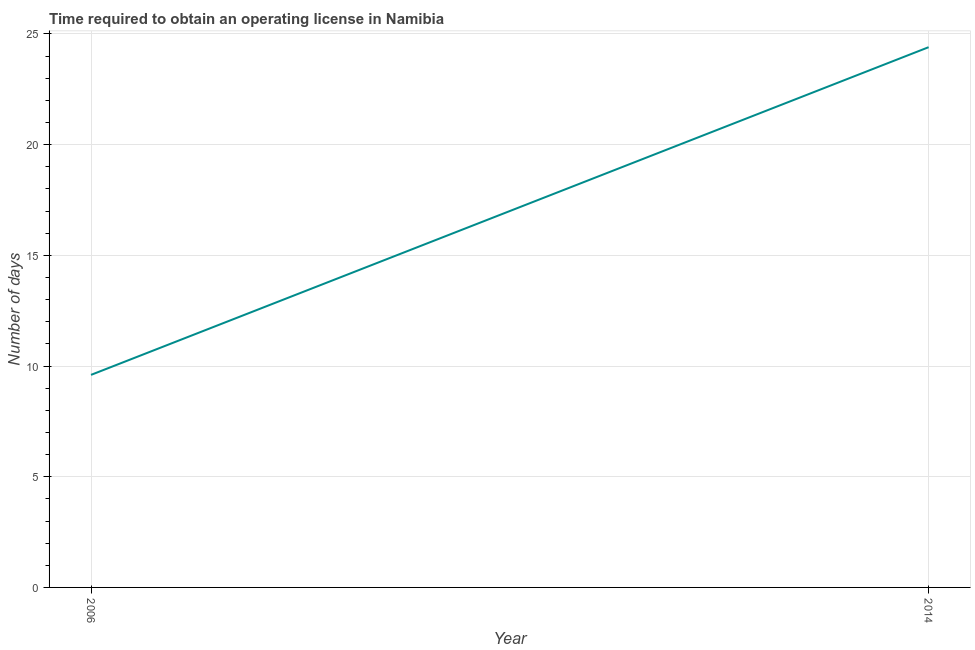What is the number of days to obtain operating license in 2014?
Your answer should be very brief. 24.4. Across all years, what is the maximum number of days to obtain operating license?
Your answer should be very brief. 24.4. In which year was the number of days to obtain operating license maximum?
Your answer should be compact. 2014. What is the sum of the number of days to obtain operating license?
Provide a short and direct response. 34. What is the difference between the number of days to obtain operating license in 2006 and 2014?
Provide a short and direct response. -14.8. What is the average number of days to obtain operating license per year?
Keep it short and to the point. 17. What is the median number of days to obtain operating license?
Ensure brevity in your answer.  17. In how many years, is the number of days to obtain operating license greater than 6 days?
Offer a terse response. 2. Do a majority of the years between 2006 and 2014 (inclusive) have number of days to obtain operating license greater than 5 days?
Offer a very short reply. Yes. What is the ratio of the number of days to obtain operating license in 2006 to that in 2014?
Keep it short and to the point. 0.39. Is the number of days to obtain operating license in 2006 less than that in 2014?
Provide a succinct answer. Yes. Are the values on the major ticks of Y-axis written in scientific E-notation?
Offer a terse response. No. Does the graph contain grids?
Provide a succinct answer. Yes. What is the title of the graph?
Provide a short and direct response. Time required to obtain an operating license in Namibia. What is the label or title of the Y-axis?
Provide a succinct answer. Number of days. What is the Number of days of 2006?
Your response must be concise. 9.6. What is the Number of days in 2014?
Make the answer very short. 24.4. What is the difference between the Number of days in 2006 and 2014?
Provide a short and direct response. -14.8. What is the ratio of the Number of days in 2006 to that in 2014?
Ensure brevity in your answer.  0.39. 